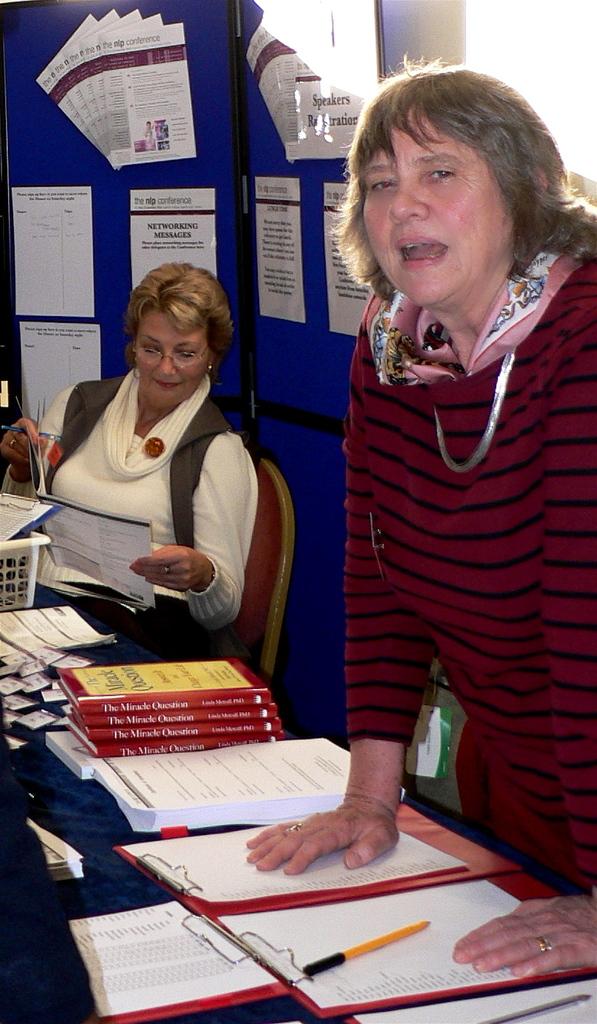What kind of messages are advertised behind the lady with short hair?
Your response must be concise. Networking. 